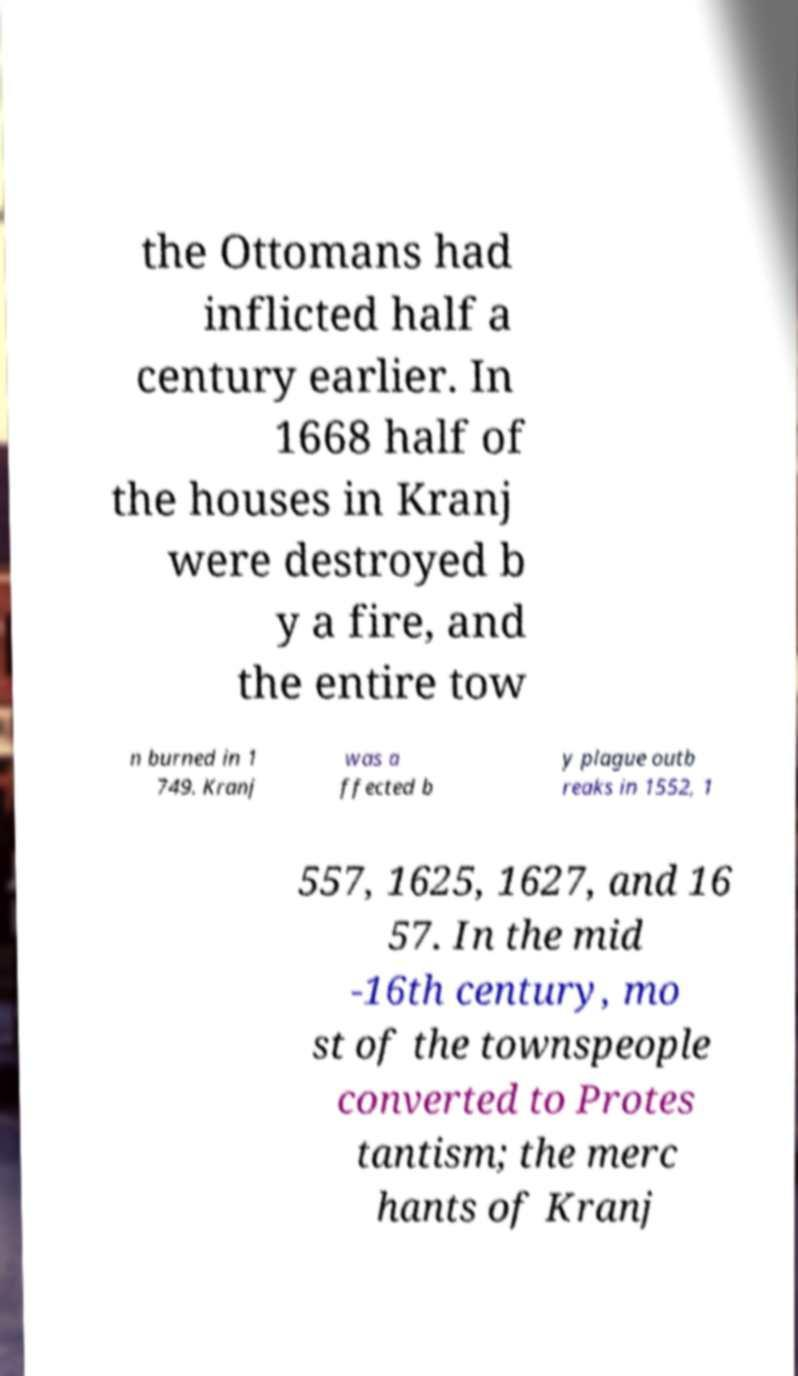Please read and relay the text visible in this image. What does it say? the Ottomans had inflicted half a century earlier. In 1668 half of the houses in Kranj were destroyed b y a fire, and the entire tow n burned in 1 749. Kranj was a ffected b y plague outb reaks in 1552, 1 557, 1625, 1627, and 16 57. In the mid -16th century, mo st of the townspeople converted to Protes tantism; the merc hants of Kranj 